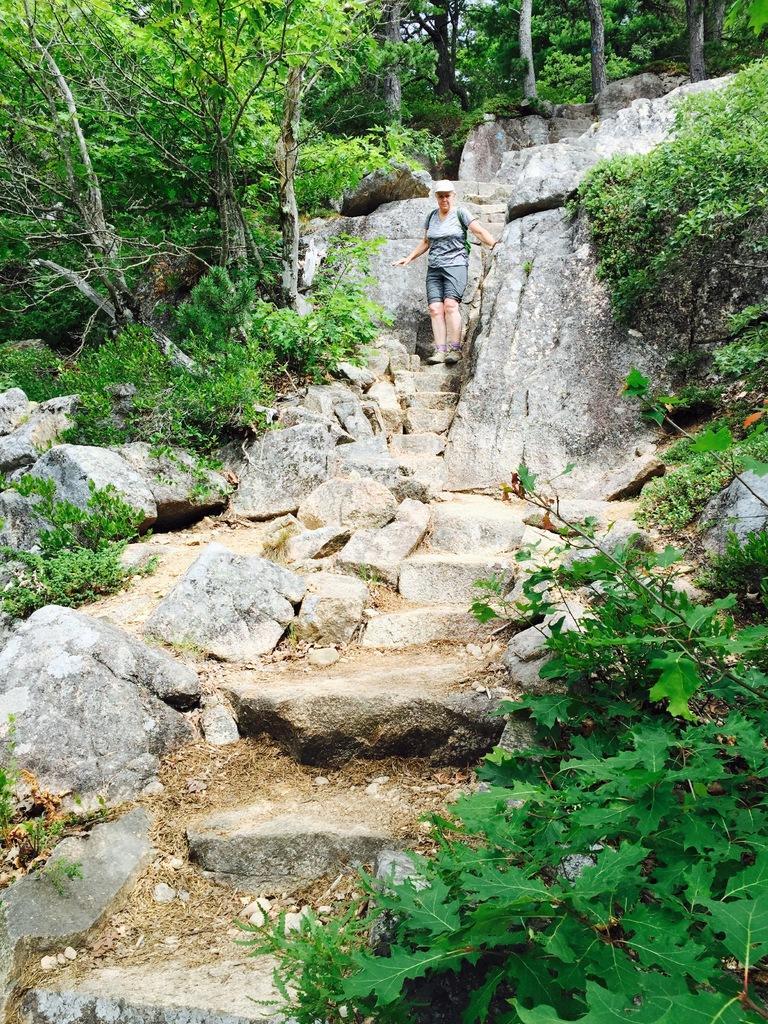Describe this image in one or two sentences. In this image we can see a person. We can also see the steps on the hill. Image also consists of rocks, plants and also the trees. 